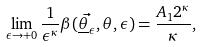Convert formula to latex. <formula><loc_0><loc_0><loc_500><loc_500>\lim _ { \epsilon \to + 0 } \frac { 1 } { \epsilon ^ { \kappa } } \beta ( \vec { \underline { \theta } _ { \epsilon } } , \theta , \epsilon ) = \frac { A _ { 1 } 2 ^ { \kappa } } { \kappa } ,</formula> 